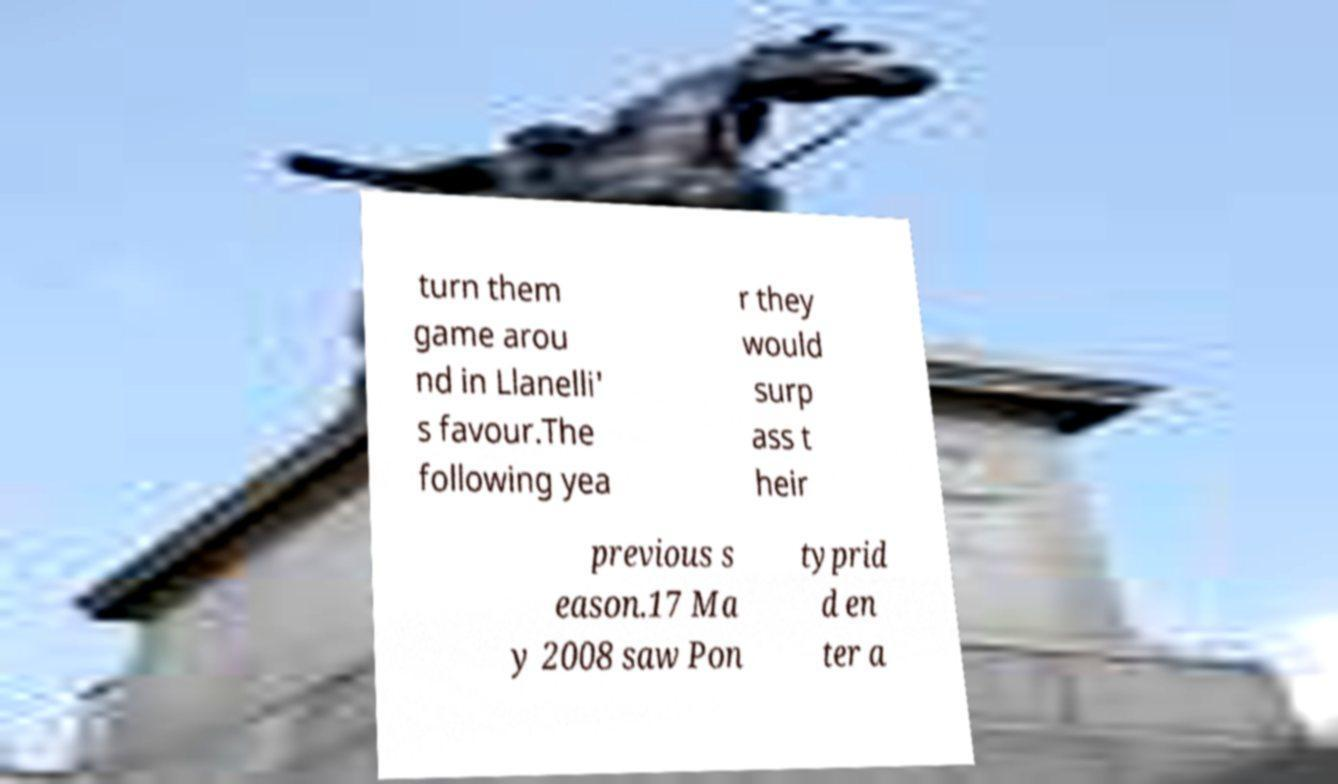What messages or text are displayed in this image? I need them in a readable, typed format. turn them game arou nd in Llanelli' s favour.The following yea r they would surp ass t heir previous s eason.17 Ma y 2008 saw Pon typrid d en ter a 